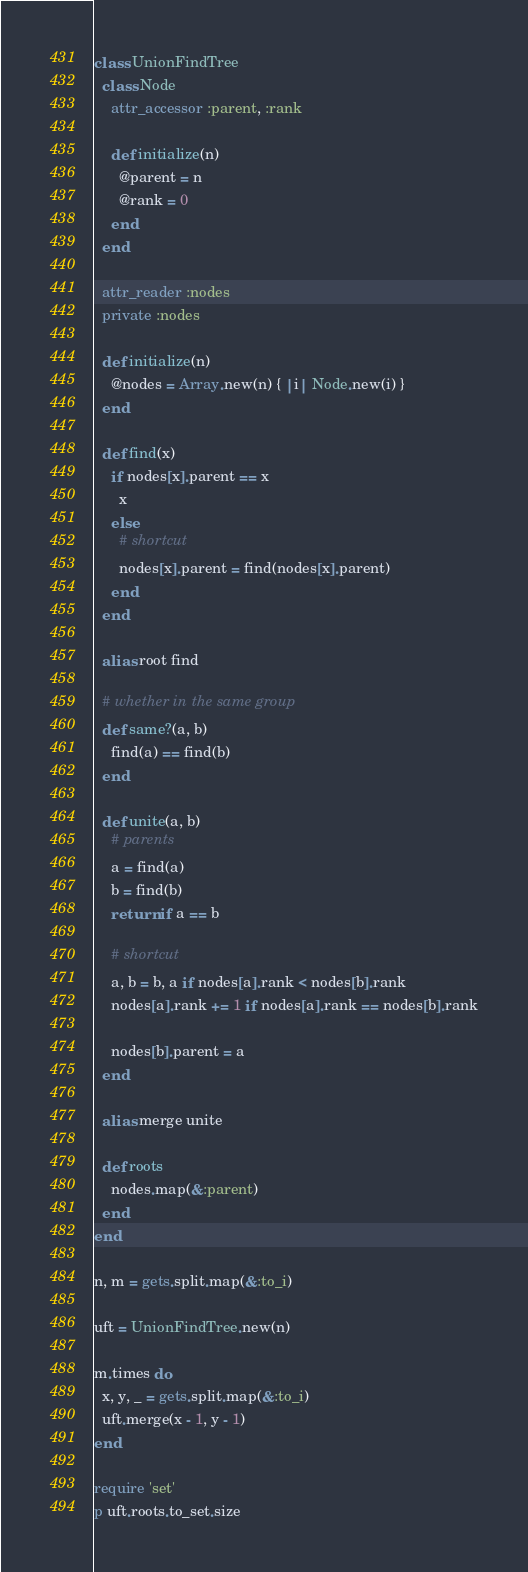Convert code to text. <code><loc_0><loc_0><loc_500><loc_500><_Ruby_>class UnionFindTree
  class Node
    attr_accessor :parent, :rank

    def initialize(n)
      @parent = n
      @rank = 0
    end
  end

  attr_reader :nodes
  private :nodes

  def initialize(n)
    @nodes = Array.new(n) { |i| Node.new(i) }
  end

  def find(x)
    if nodes[x].parent == x
      x
    else
      # shortcut
      nodes[x].parent = find(nodes[x].parent)
    end
  end

  alias root find

  # whether in the same group
  def same?(a, b)
    find(a) == find(b)
  end

  def unite(a, b)
    # parents
    a = find(a)
    b = find(b)
    return if a == b

    # shortcut
    a, b = b, a if nodes[a].rank < nodes[b].rank
    nodes[a].rank += 1 if nodes[a].rank == nodes[b].rank

    nodes[b].parent = a
  end

  alias merge unite

  def roots
    nodes.map(&:parent)
  end
end

n, m = gets.split.map(&:to_i)

uft = UnionFindTree.new(n)

m.times do
  x, y, _ = gets.split.map(&:to_i)
  uft.merge(x - 1, y - 1)
end

require 'set'
p uft.roots.to_set.size
</code> 